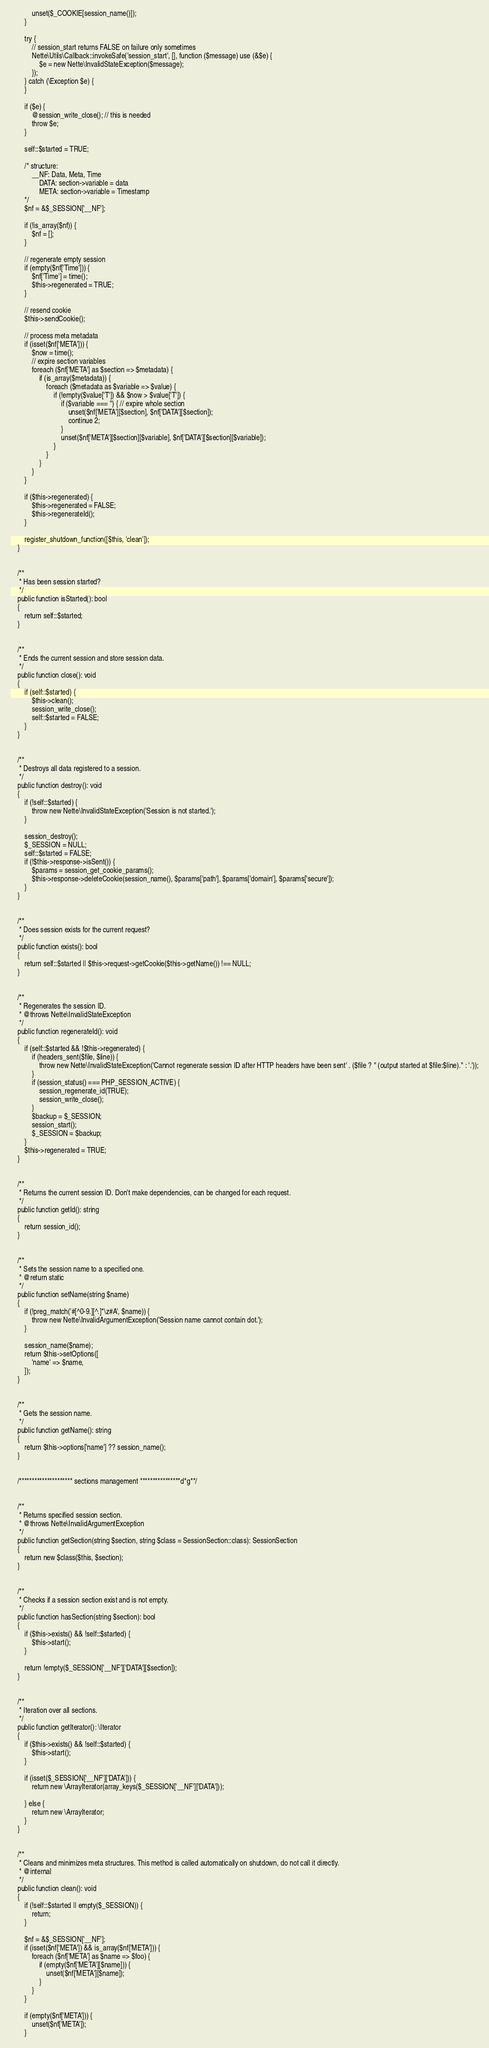<code> <loc_0><loc_0><loc_500><loc_500><_PHP_>			unset($_COOKIE[session_name()]);
		}

		try {
			// session_start returns FALSE on failure only sometimes
			Nette\Utils\Callback::invokeSafe('session_start', [], function ($message) use (&$e) {
				$e = new Nette\InvalidStateException($message);
			});
		} catch (\Exception $e) {
		}

		if ($e) {
			@session_write_close(); // this is needed
			throw $e;
		}

		self::$started = TRUE;

		/* structure:
			__NF: Data, Meta, Time
				DATA: section->variable = data
				META: section->variable = Timestamp
		*/
		$nf = &$_SESSION['__NF'];

		if (!is_array($nf)) {
			$nf = [];
		}

		// regenerate empty session
		if (empty($nf['Time'])) {
			$nf['Time'] = time();
			$this->regenerated = TRUE;
		}

		// resend cookie
		$this->sendCookie();

		// process meta metadata
		if (isset($nf['META'])) {
			$now = time();
			// expire section variables
			foreach ($nf['META'] as $section => $metadata) {
				if (is_array($metadata)) {
					foreach ($metadata as $variable => $value) {
						if (!empty($value['T']) && $now > $value['T']) {
							if ($variable === '') { // expire whole section
								unset($nf['META'][$section], $nf['DATA'][$section]);
								continue 2;
							}
							unset($nf['META'][$section][$variable], $nf['DATA'][$section][$variable]);
						}
					}
				}
			}
		}

		if ($this->regenerated) {
			$this->regenerated = FALSE;
			$this->regenerateId();
		}

		register_shutdown_function([$this, 'clean']);
	}


	/**
	 * Has been session started?
	 */
	public function isStarted(): bool
	{
		return self::$started;
	}


	/**
	 * Ends the current session and store session data.
	 */
	public function close(): void
	{
		if (self::$started) {
			$this->clean();
			session_write_close();
			self::$started = FALSE;
		}
	}


	/**
	 * Destroys all data registered to a session.
	 */
	public function destroy(): void
	{
		if (!self::$started) {
			throw new Nette\InvalidStateException('Session is not started.');
		}

		session_destroy();
		$_SESSION = NULL;
		self::$started = FALSE;
		if (!$this->response->isSent()) {
			$params = session_get_cookie_params();
			$this->response->deleteCookie(session_name(), $params['path'], $params['domain'], $params['secure']);
		}
	}


	/**
	 * Does session exists for the current request?
	 */
	public function exists(): bool
	{
		return self::$started || $this->request->getCookie($this->getName()) !== NULL;
	}


	/**
	 * Regenerates the session ID.
	 * @throws Nette\InvalidStateException
	 */
	public function regenerateId(): void
	{
		if (self::$started && !$this->regenerated) {
			if (headers_sent($file, $line)) {
				throw new Nette\InvalidStateException('Cannot regenerate session ID after HTTP headers have been sent' . ($file ? " (output started at $file:$line)." : '.'));
			}
			if (session_status() === PHP_SESSION_ACTIVE) {
				session_regenerate_id(TRUE);
				session_write_close();
			}
			$backup = $_SESSION;
			session_start();
			$_SESSION = $backup;
		}
		$this->regenerated = TRUE;
	}


	/**
	 * Returns the current session ID. Don't make dependencies, can be changed for each request.
	 */
	public function getId(): string
	{
		return session_id();
	}


	/**
	 * Sets the session name to a specified one.
	 * @return static
	 */
	public function setName(string $name)
	{
		if (!preg_match('#[^0-9.][^.]*\z#A', $name)) {
			throw new Nette\InvalidArgumentException('Session name cannot contain dot.');
		}

		session_name($name);
		return $this->setOptions([
			'name' => $name,
		]);
	}


	/**
	 * Gets the session name.
	 */
	public function getName(): string
	{
		return $this->options['name'] ?? session_name();
	}


	/********************* sections management ****************d*g**/


	/**
	 * Returns specified session section.
	 * @throws Nette\InvalidArgumentException
	 */
	public function getSection(string $section, string $class = SessionSection::class): SessionSection
	{
		return new $class($this, $section);
	}


	/**
	 * Checks if a session section exist and is not empty.
	 */
	public function hasSection(string $section): bool
	{
		if ($this->exists() && !self::$started) {
			$this->start();
		}

		return !empty($_SESSION['__NF']['DATA'][$section]);
	}


	/**
	 * Iteration over all sections.
	 */
	public function getIterator(): \Iterator
	{
		if ($this->exists() && !self::$started) {
			$this->start();
		}

		if (isset($_SESSION['__NF']['DATA'])) {
			return new \ArrayIterator(array_keys($_SESSION['__NF']['DATA']));

		} else {
			return new \ArrayIterator;
		}
	}


	/**
	 * Cleans and minimizes meta structures. This method is called automatically on shutdown, do not call it directly.
	 * @internal
	 */
	public function clean(): void
	{
		if (!self::$started || empty($_SESSION)) {
			return;
		}

		$nf = &$_SESSION['__NF'];
		if (isset($nf['META']) && is_array($nf['META'])) {
			foreach ($nf['META'] as $name => $foo) {
				if (empty($nf['META'][$name])) {
					unset($nf['META'][$name]);
				}
			}
		}

		if (empty($nf['META'])) {
			unset($nf['META']);
		}
</code> 